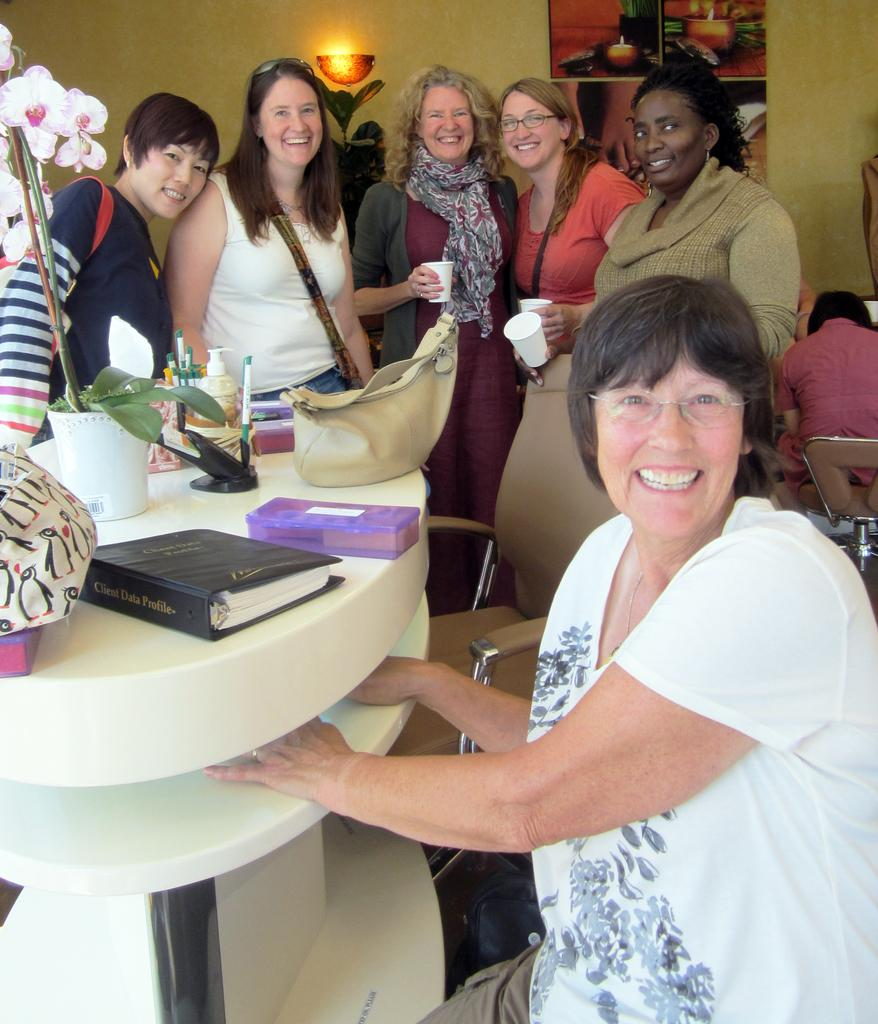<image>
Write a terse but informative summary of the picture. a bumch of woman at a meeting with a book of client data material 